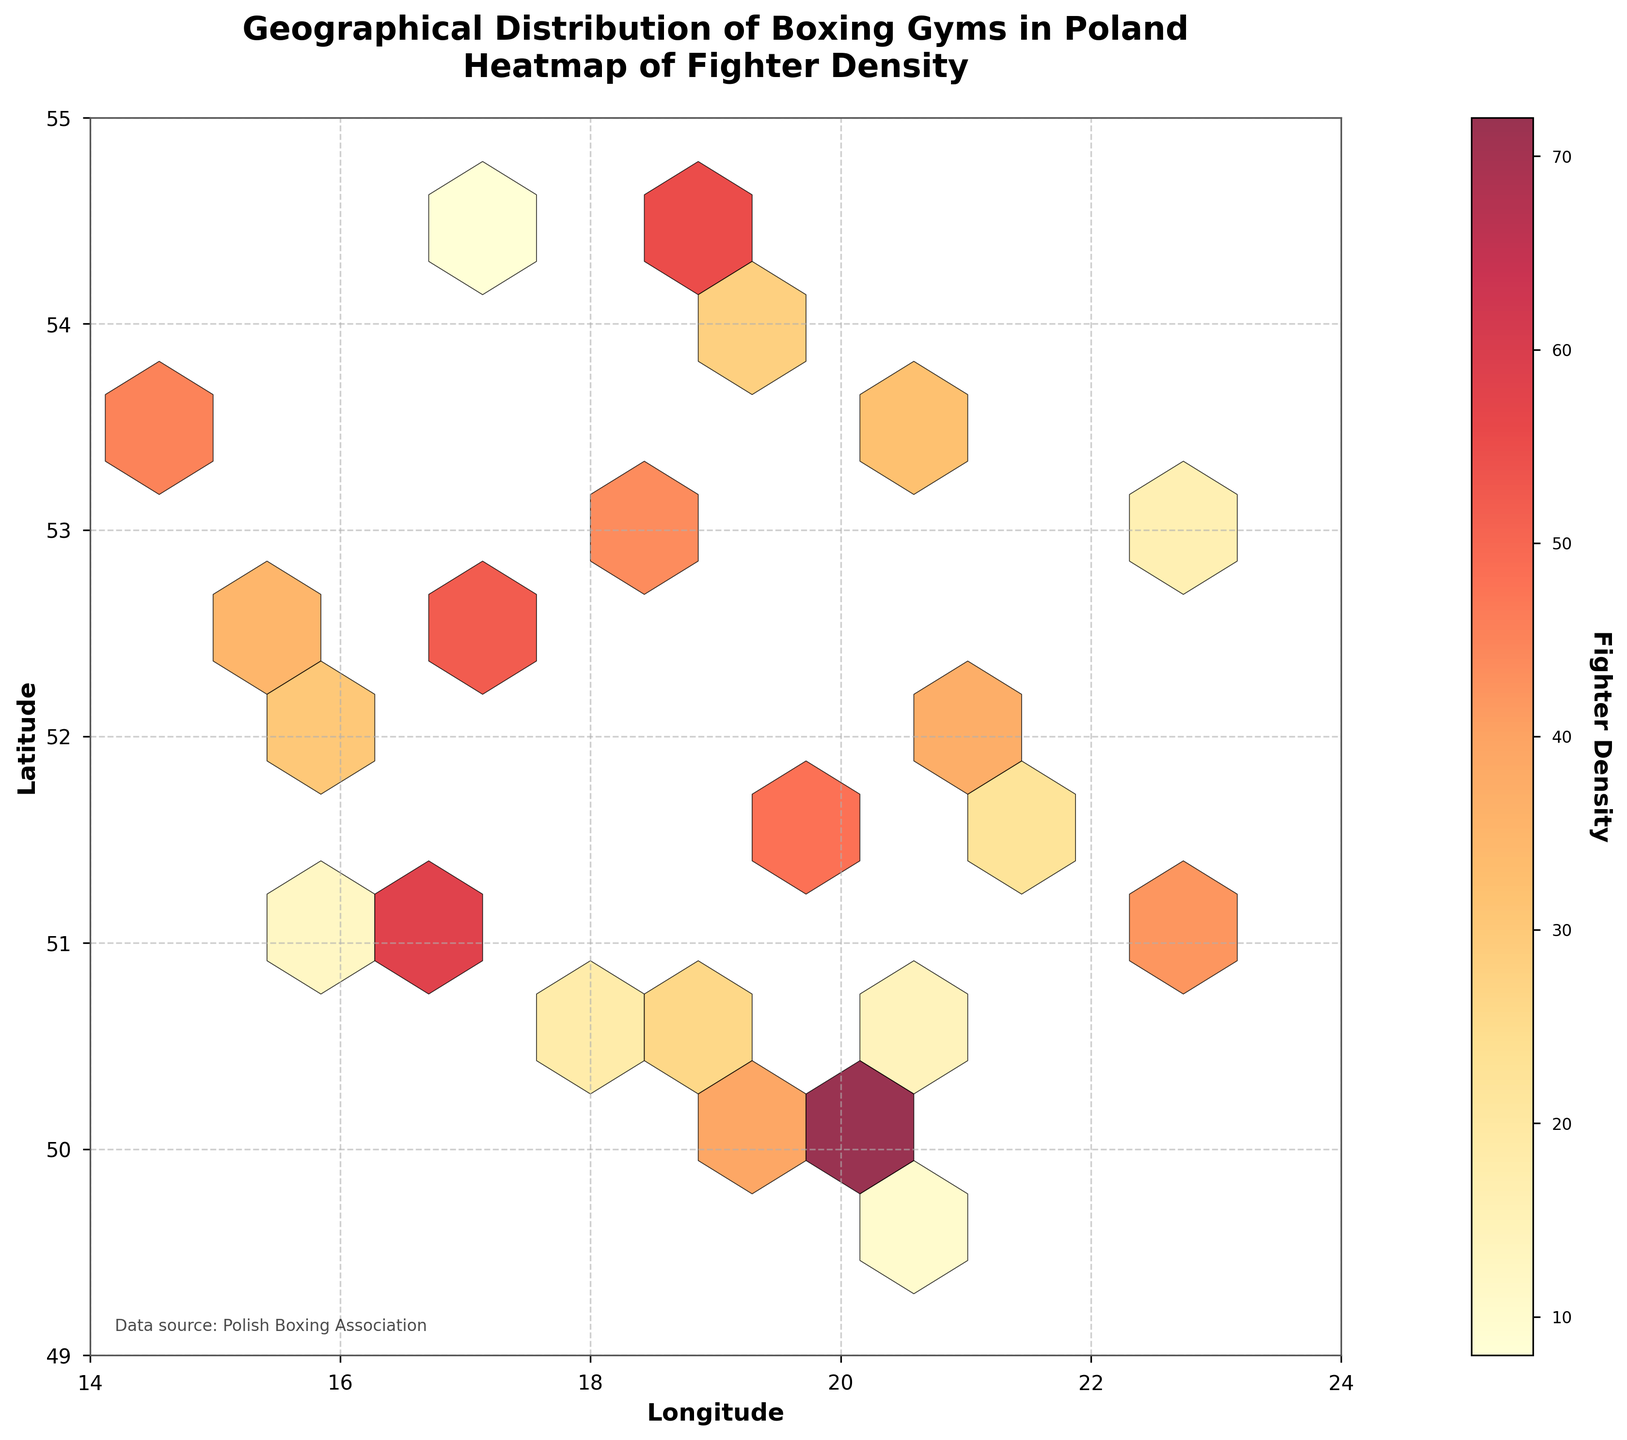How many hexagonal bins are shown on the plot? The plot is created using a gridsize of 10 by 10 hexagons. Each grid cell corresponds to a hexagonal bin on the plot. By looking at the plot, you can count the number of filled hexagons.
Answer: 100 (total hex bins) What is the highest fighter density represented in the plot? The color bar on the side of the plot indicates the fighter density, with the darkest red denoting the highest density. By locating the darkest red bin on the plot, you can determine the maximum fighter density.
Answer: 85 Which city shows the highest density of fighters? The plot shows the latitude and longitude of boxing gyms. The city with the coordinates (52.2297, 21.0122) has the highest density of 85, according to the dataset provided.
Answer: Warsaw How does the density of fighters in Warsaw compare to that in Krakow? By checking the data and plot, we can see Warsaw has coordinates (52.2297, 21.0122) with a density of 85, whereas Krakow has coordinates (50.0647, 19.9450) with a density of 72. Comparing these values shows Warsaw has a higher density.
Answer: Warsaw > Krakow What is the general trend in fighter density as we move from west to east Poland? By observing the density of colors from left (west) to right (east) on the plot, the color becomes darker indicating higher density. Hence fighter density tends to be higher in the eastern locations.
Answer: Increasing What city is represented by latitude 51.7592 and longitude 19.4559, and what is its fighter density? By matching the given coordinates with the data, the city is Łódź, and checking the dataset indicates a density of 48.
Answer: Łódź, 48 Are there any areas with latitude above 53 that show high fighter densities? By analyzing the top portion of the plot (latitude>53), we see some of the bins are darker, indicating relatively high densities. Specifically, locations like 53.1235, 53.4289 have densities of 63 and 45 respectively.
Answer: Yes Is there an observable cluster of boxing gyms in any specific region of Poland? Observing the plot, there is a noticeable cluster of dark bins around the central and eastern parts of Poland.
Answer: Yes, central and eastern regions What is the approximate fighter density for coordinates around 54 latitude and 18 longitude? By locating the nearest bin to (54, 18) on the plot, which is around Gdańsk, we refer to the approximate color/density value in that region which is indicated around 55.
Answer: Around 55 Which latitude range shows the widest variation in fighter density? Analyzing the plot vertically, the range spanning latitudes 51 to 52 shows both dense and sparse populations indicated by dark and light hex bins.
Answer: 51 to 52 